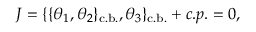<formula> <loc_0><loc_0><loc_500><loc_500>J = \{ \{ \theta _ { 1 } , \theta _ { 2 } \} _ { c . b . } , \theta _ { 3 } \} _ { c . b . } + c . p . = 0 ,</formula> 